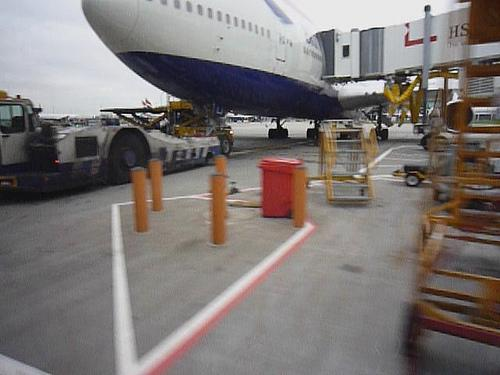Write a concise description of the primary elements in the scene. Image showcases an airplane, loading bridge, pushback tractor, and ground markings at an airport. Mention the most noticeable object in the image and its location. A blue and white airplane located at the left-center of the image, surrounded by various airport equipment and facilities. Provide a brief overview of the setting in the image. An airplane at an airport with various equipment, ground markings, and vehicles nearby, such as loading hallways, pushback tractors, and maintenance ladders. Describe the scene as if you were giving directions to someone. Find the blue and white airplane near the loading bridge, and you'll see a pushback tractor, maintenance ladder, and yellow pillars nearby. Explain the image from the perspective of the airport personnel. As airport staff, we ensure that the blue and white airplane is connected to the loading bridge, pushback tractor is in place, and maintenance ladders are available to reach higher points on the aircraft. Describe the airplane and its surroundings in a casual tone. There's this cool airplane with a blue underbelly, just hangin' at the airport, and there's like some loading bridges, tractors, ladders and stuff near it, you know? Write a brief description of the colors visible in the image. A colorful assortment of blue and white on the airplane, yellow on the pillars and ladders, and red on the garbage can and ground markings. Create a short rhymed verse about the image. Yellow pillars standing clear. Use metaphorical language to describe the image. An ocean of blue and white metal soared above a fleet of colorful support vehicles, all dancing on the concrete stage of their airport home. Imagine you are telling a friend about an interesting scene you saw, and describe the image. You wouldn't believe it! I saw this huge airplane with a blue underbelly and all these cool airport gadgets around it like a loading bridge, a pushback tractor, and bright yellow pillars. 